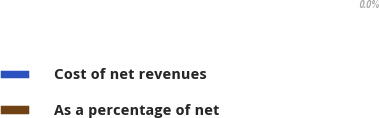<chart> <loc_0><loc_0><loc_500><loc_500><pie_chart><fcel>Cost of net revenues<fcel>As a percentage of net<nl><fcel>100.0%<fcel>0.0%<nl></chart> 